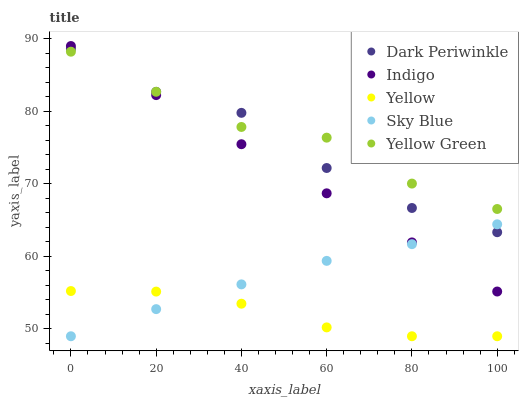Does Yellow have the minimum area under the curve?
Answer yes or no. Yes. Does Yellow Green have the maximum area under the curve?
Answer yes or no. Yes. Does Indigo have the minimum area under the curve?
Answer yes or no. No. Does Indigo have the maximum area under the curve?
Answer yes or no. No. Is Indigo the smoothest?
Answer yes or no. Yes. Is Dark Periwinkle the roughest?
Answer yes or no. Yes. Is Dark Periwinkle the smoothest?
Answer yes or no. No. Is Indigo the roughest?
Answer yes or no. No. Does Sky Blue have the lowest value?
Answer yes or no. Yes. Does Indigo have the lowest value?
Answer yes or no. No. Does Indigo have the highest value?
Answer yes or no. Yes. Does Dark Periwinkle have the highest value?
Answer yes or no. No. Is Yellow less than Indigo?
Answer yes or no. Yes. Is Indigo greater than Yellow?
Answer yes or no. Yes. Does Dark Periwinkle intersect Indigo?
Answer yes or no. Yes. Is Dark Periwinkle less than Indigo?
Answer yes or no. No. Is Dark Periwinkle greater than Indigo?
Answer yes or no. No. Does Yellow intersect Indigo?
Answer yes or no. No. 